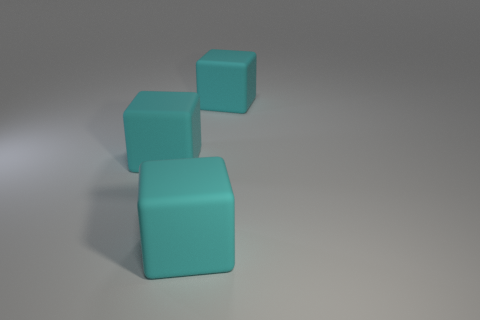Is there a cyan rubber block?
Keep it short and to the point. Yes. What number of big things are there?
Your answer should be compact. 3. 